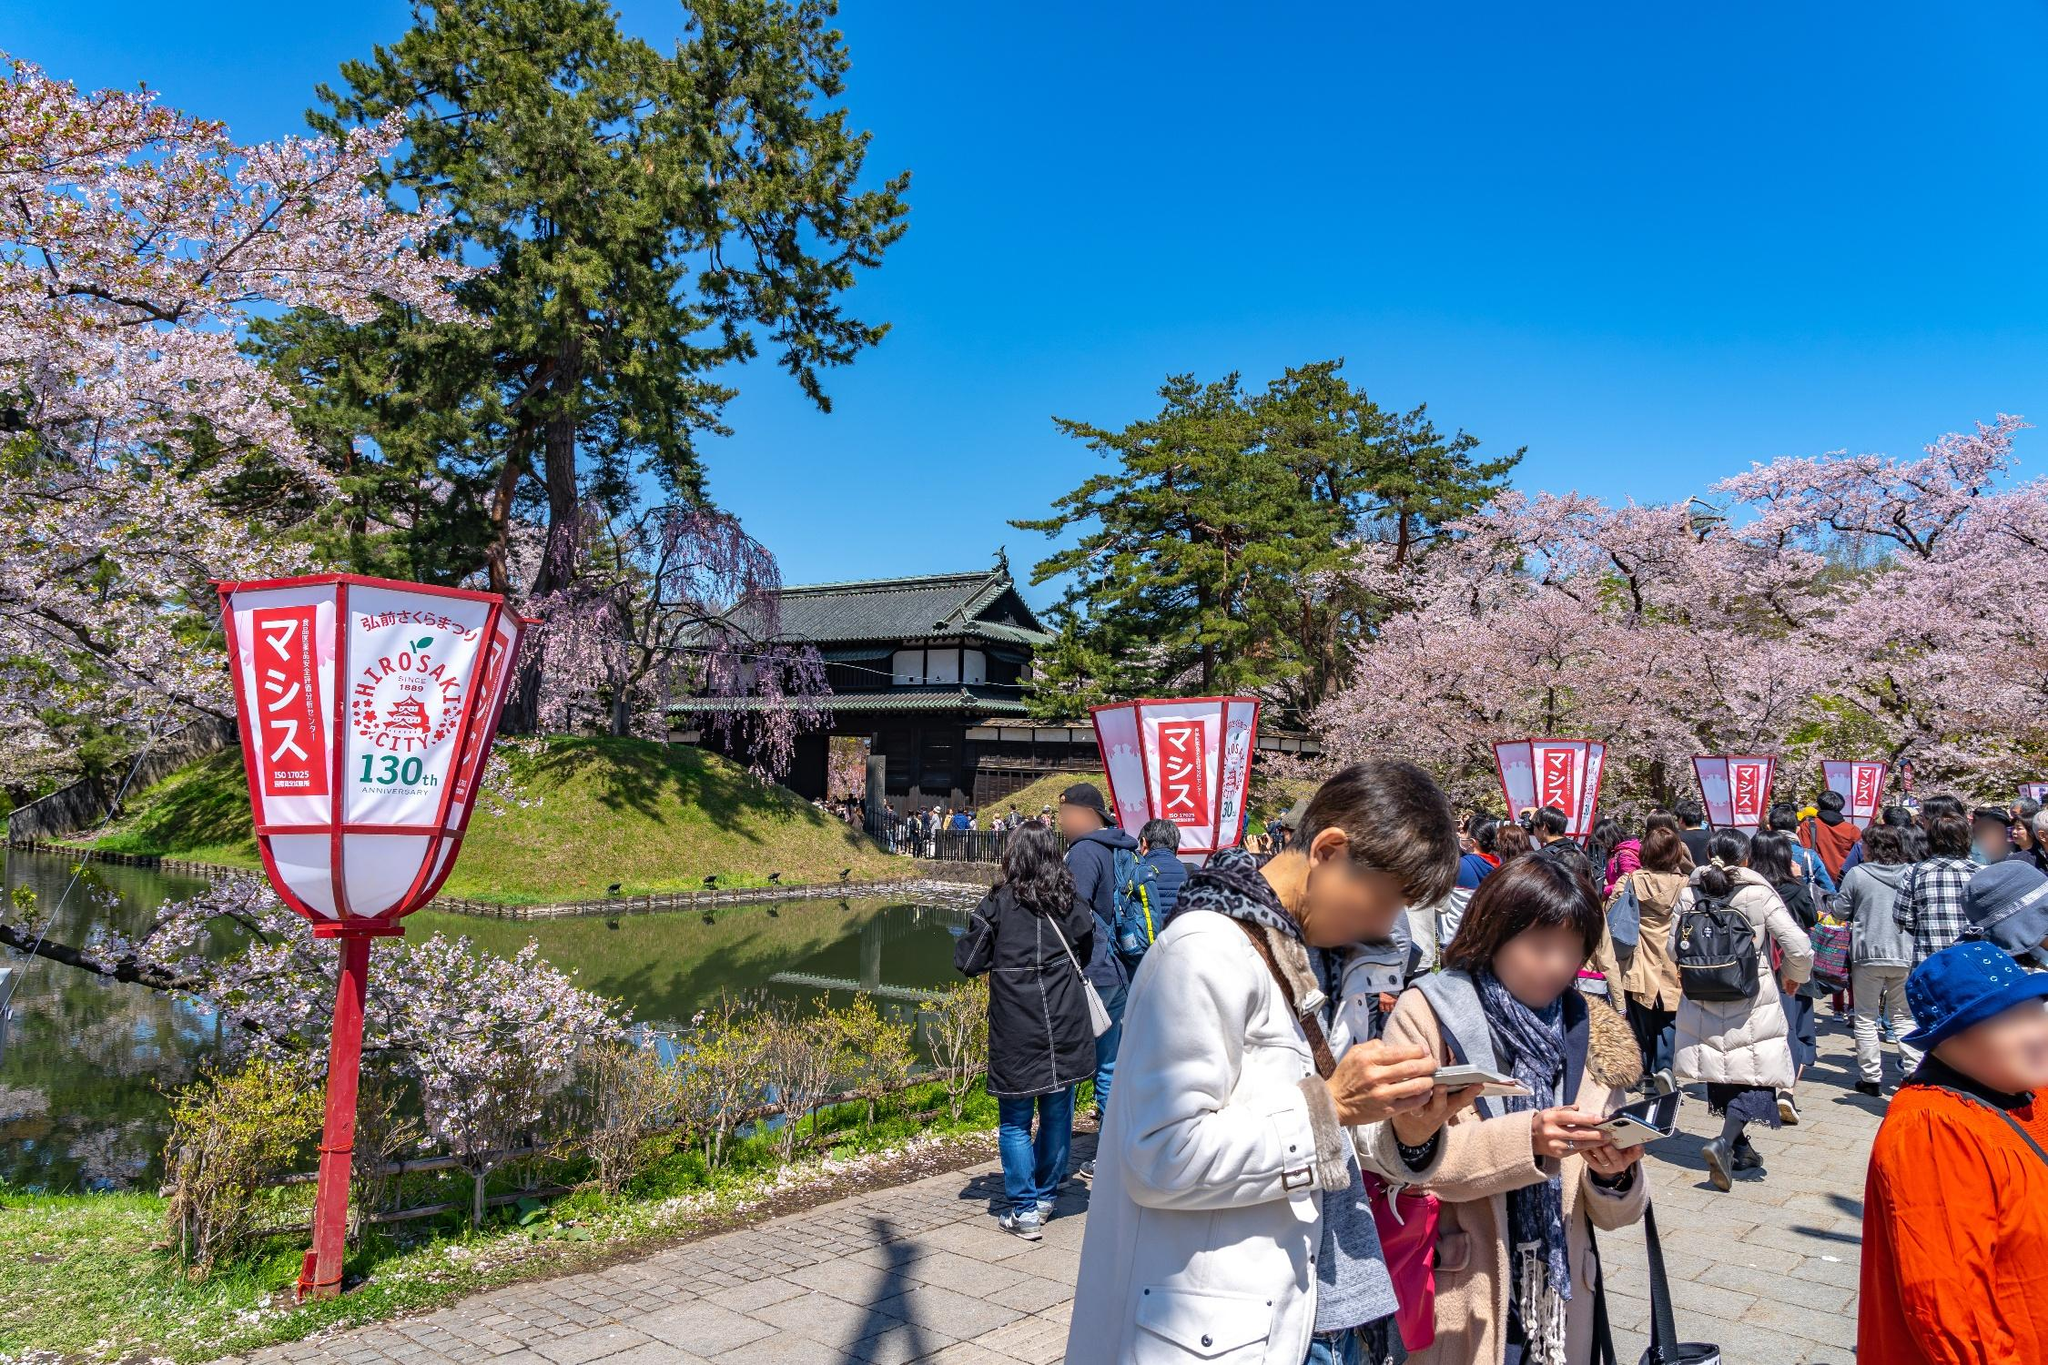If you were to write a poem inspired by this scene, how would it start? Beneath the castle's shadowed grace,
A sea of pink in soft embrace,
Petals whisper on the breeze,
A timeless dance among the trees. 